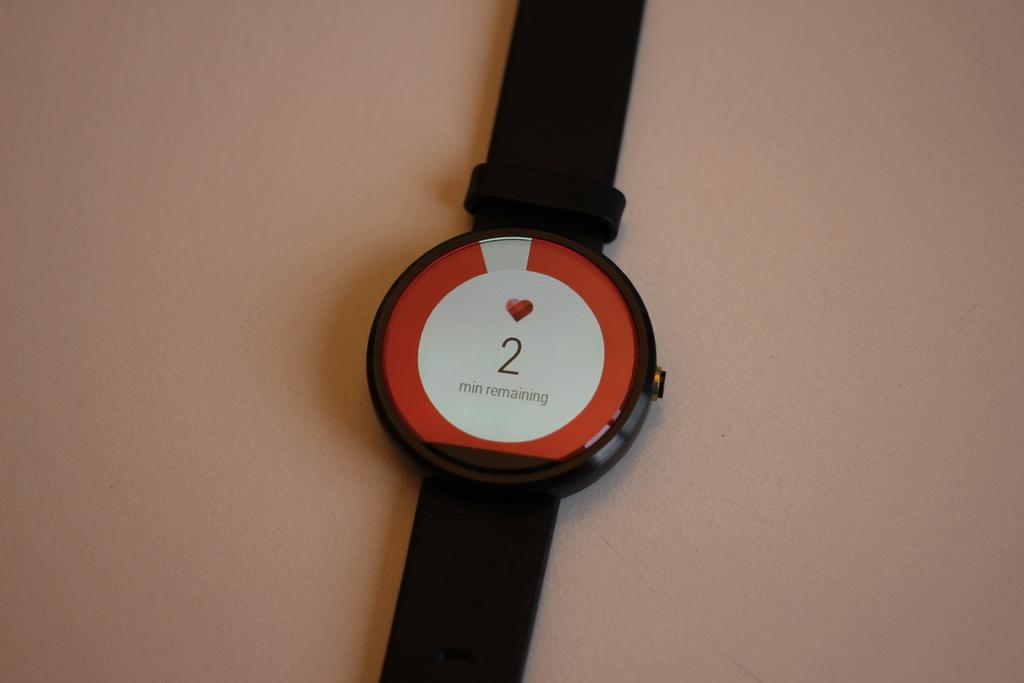<image>
Present a compact description of the photo's key features. A watch that says "2 min remaining" has a heart on its face. 